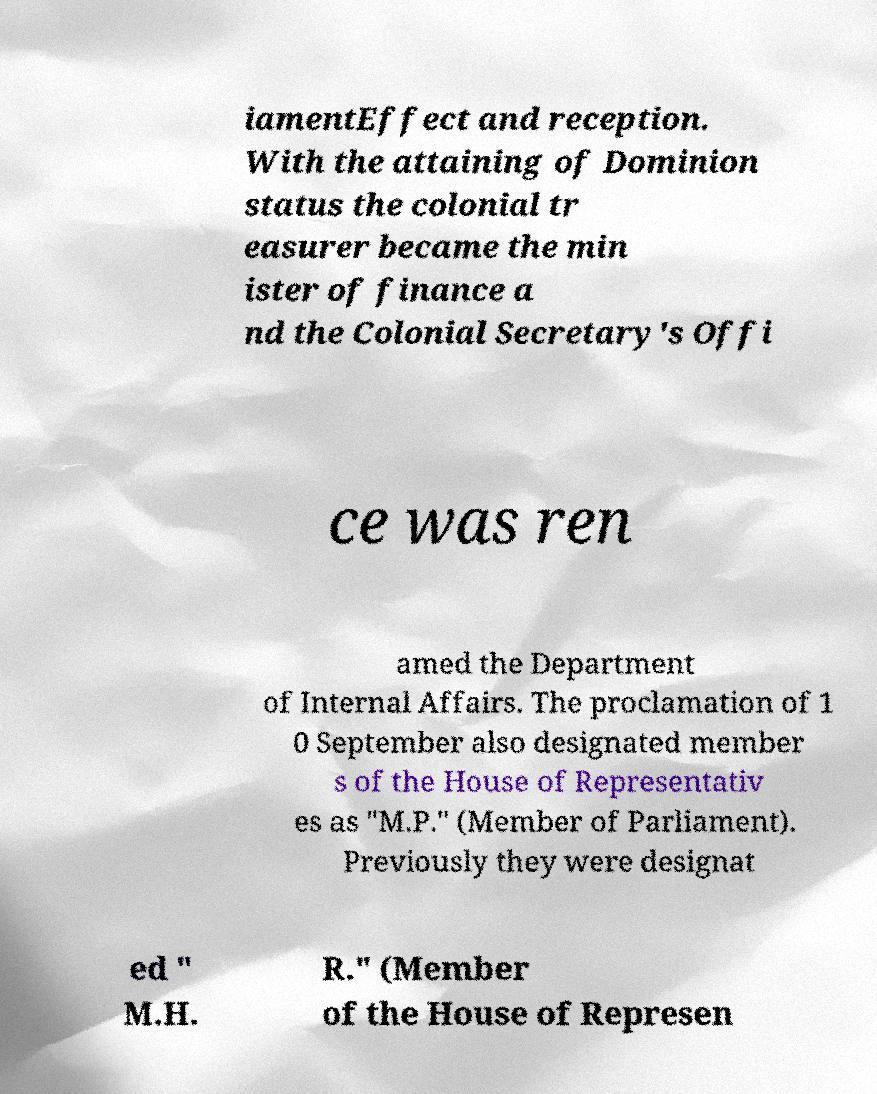What messages or text are displayed in this image? I need them in a readable, typed format. iamentEffect and reception. With the attaining of Dominion status the colonial tr easurer became the min ister of finance a nd the Colonial Secretary's Offi ce was ren amed the Department of Internal Affairs. The proclamation of 1 0 September also designated member s of the House of Representativ es as "M.P." (Member of Parliament). Previously they were designat ed " M.H. R." (Member of the House of Represen 